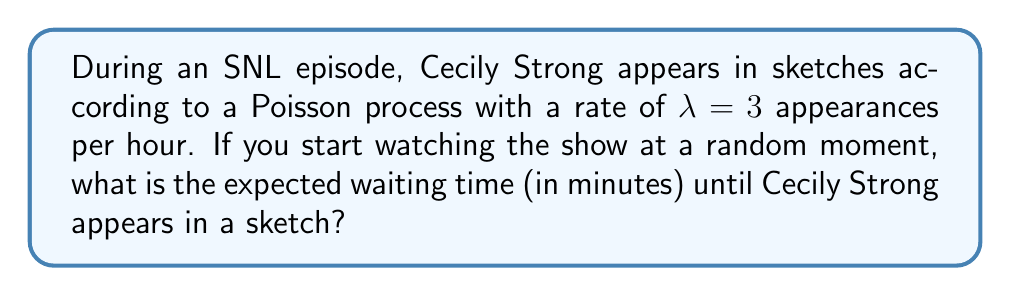Show me your answer to this math problem. Let's approach this step-by-step:

1) In a Poisson process, the waiting time until the next event follows an exponential distribution.

2) The rate parameter $\lambda$ is given as 3 appearances per hour.

3) For an exponential distribution, the expected value (mean waiting time) is given by:

   $$E[X] = \frac{1}{\lambda}$$

4) However, $\lambda$ is currently in units of appearances per hour. We need to convert it to appearances per minute:

   $$\lambda_{minute} = \frac{3}{60} = 0.05 \text{ appearances per minute}$$

5) Now we can calculate the expected waiting time:

   $$E[X] = \frac{1}{\lambda_{minute}} = \frac{1}{0.05} = 20 \text{ minutes}$$

Therefore, the expected waiting time until Cecily Strong appears in a sketch is 20 minutes.
Answer: 20 minutes 